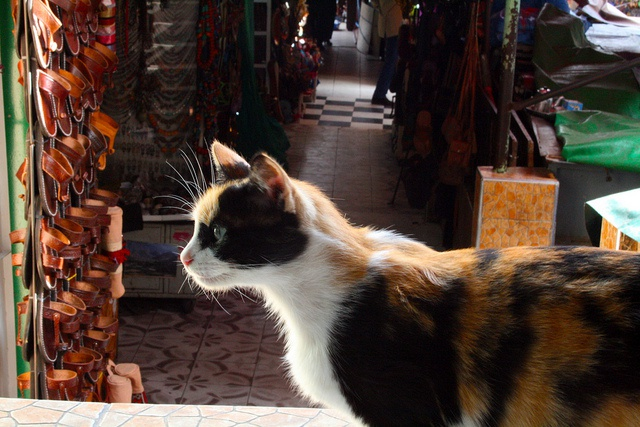Describe the objects in this image and their specific colors. I can see cat in darkgreen, black, maroon, darkgray, and ivory tones, people in darkgreen, black, maroon, lightgray, and gray tones, and handbag in black, maroon, and darkgreen tones in this image. 